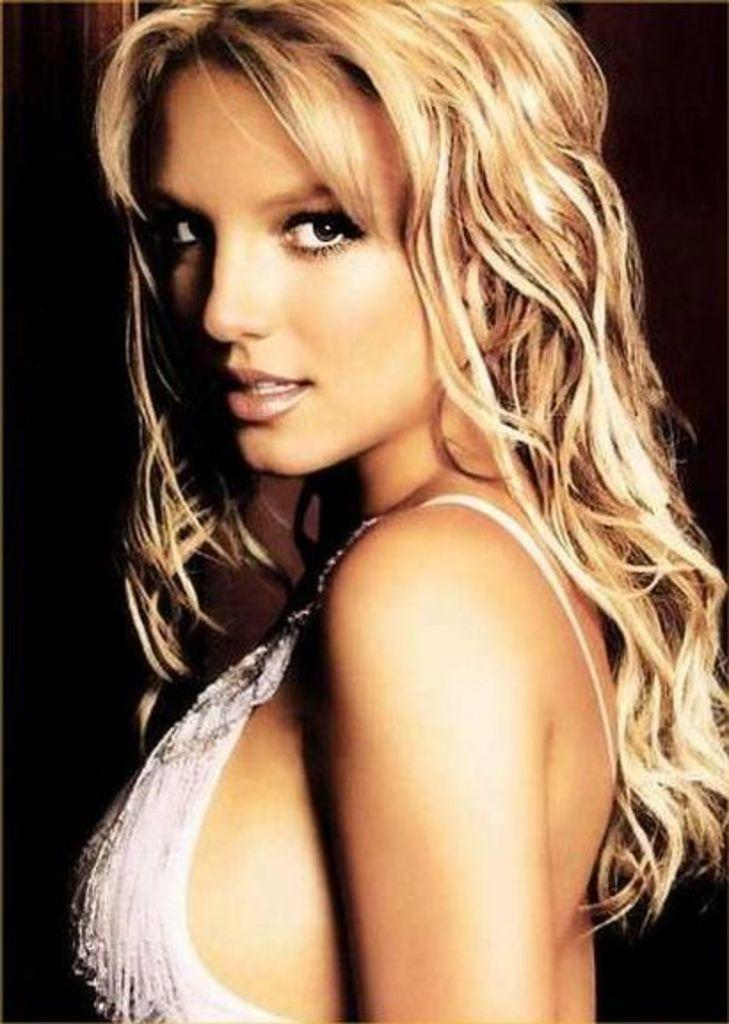What is the main subject of the image? The main subject of the image is a woman. What is the woman wearing in the image? The woman is wearing a white dress. What can be observed about the background of the image? The background of the image is dark. What type of crack can be seen in the image? There is no crack present in the image. What material is the bit made of in the image? There is no bit present in the image. 